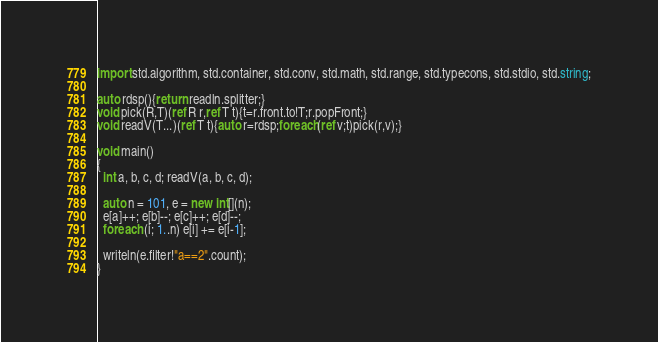Convert code to text. <code><loc_0><loc_0><loc_500><loc_500><_D_>import std.algorithm, std.container, std.conv, std.math, std.range, std.typecons, std.stdio, std.string;

auto rdsp(){return readln.splitter;}
void pick(R,T)(ref R r,ref T t){t=r.front.to!T;r.popFront;}
void readV(T...)(ref T t){auto r=rdsp;foreach(ref v;t)pick(r,v);}

void main()
{
  int a, b, c, d; readV(a, b, c, d);

  auto n = 101, e = new int[](n);
  e[a]++; e[b]--; e[c]++; e[d]--;
  foreach (i; 1..n) e[i] += e[i-1];

  writeln(e.filter!"a==2".count);
}
</code> 